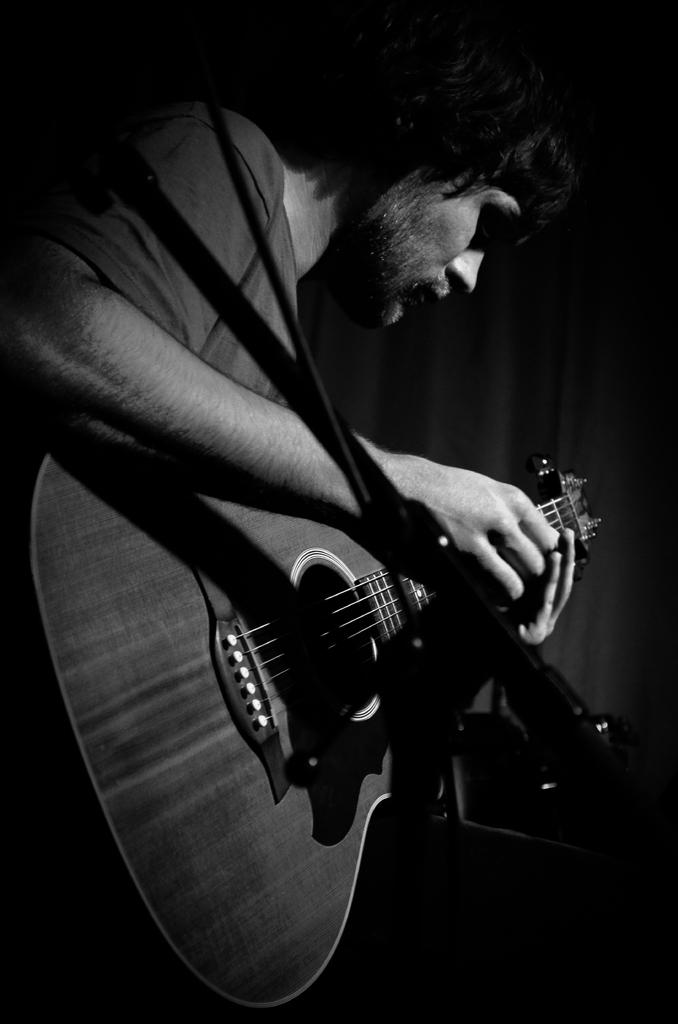What is the main subject of the image? There is a man in the image. What is the man doing in the image? The man is playing a guitar. What type of beast can be seen interacting with the man in the image? There is no beast present in the image; it only features a man playing a guitar. How does the man shake the guitar in the image? The man is not shaking the guitar in the image; he is playing it. 